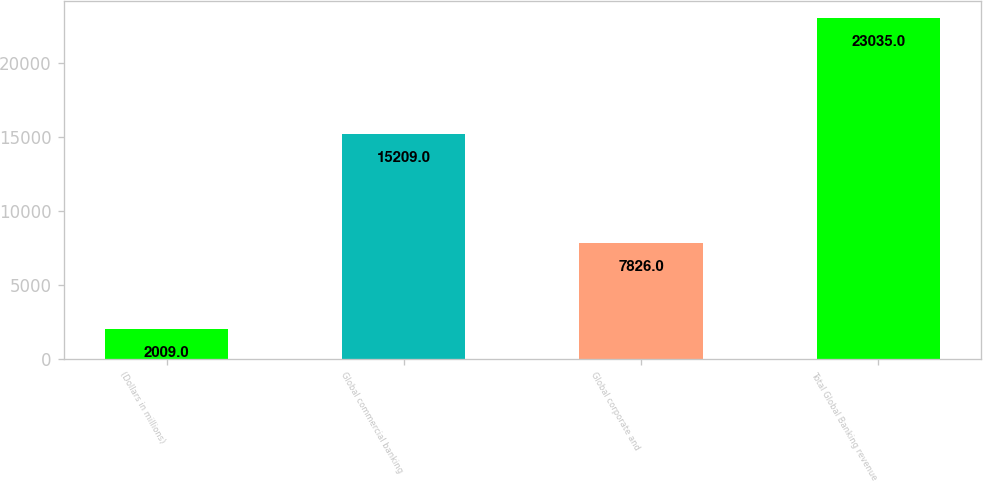Convert chart. <chart><loc_0><loc_0><loc_500><loc_500><bar_chart><fcel>(Dollars in millions)<fcel>Global commercial banking<fcel>Global corporate and<fcel>Total Global Banking revenue<nl><fcel>2009<fcel>15209<fcel>7826<fcel>23035<nl></chart> 